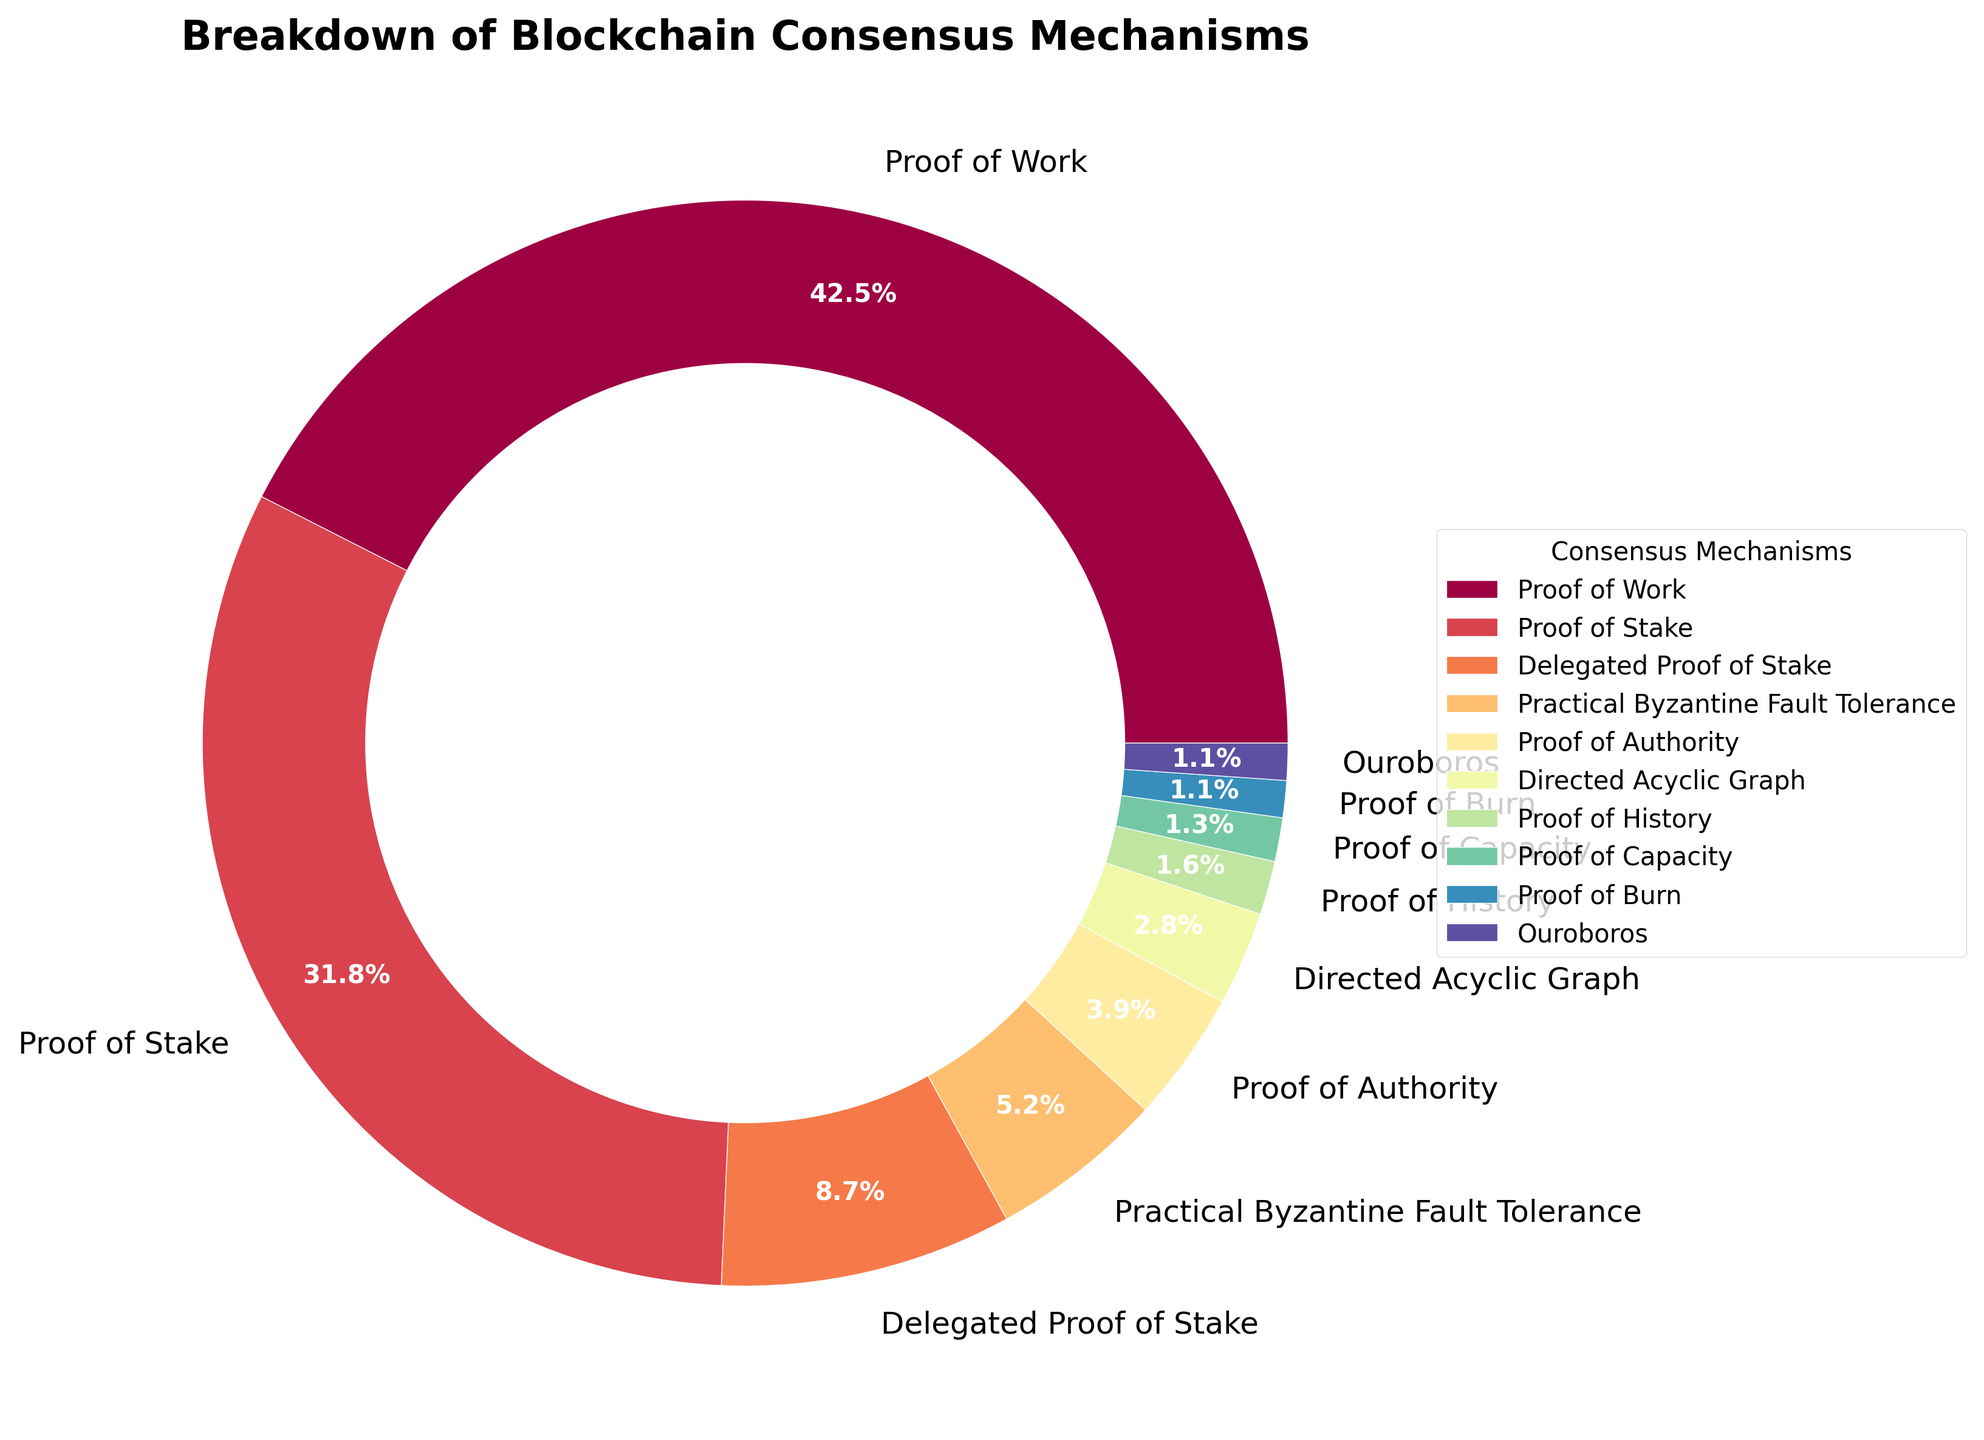What is the most commonly used blockchain consensus mechanism according to the chart? The slice representing Proof of Work is the largest part of the pie chart. Therefore, Proof of Work is the most commonly used consensus mechanism.
Answer: Proof of Work What percentage of top cryptocurrencies use Proof of Stake? The chart shows a label for Proof of Stake indicating its percentage.
Answer: 31.8% How much higher is the percentage of Proof of Work compared to Proof of Stake? Proof of Work has a percentage of 42.5%, and Proof of Stake has a percentage of 31.8%. Subtracting these two values gives the difference: 42.5% - 31.8% = 10.7%.
Answer: 10.7% Which consensus mechanisms combined make up more than 50% of the chart? Adding the percentages of each consensus mechanism, starting with the largest values: Proof of Work (42.5%) and Proof of Stake (31.8%). Their combined percentage is 42.5% + 31.8% = 74.3%, which is more than 50%.
Answer: Proof of Work and Proof of Stake List all the consensus mechanisms that have a percentage lower than 3%. Identify the slices of the pie chart that have percentages below 3%. These mechanisms are Directed Acyclic Graph (2.8%), Proof of History (1.6%), Proof of Capacity (1.3%), Proof of Burn (1.1%), and Ouroboros (1.1%).
Answer: Directed Acyclic Graph, Proof of History, Proof of Capacity, Proof of Burn, Ouroboros Which consensus mechanism occupies the smallest segment in the chart? The segment labeled with the smallest percentage represents Proof of Burn and Ouroboros, both showing 1.1%. Since they have the same percentage, either could be considered the smallest.
Answer: Proof of Burn/Ouroboros How do the percentages of Delegated Proof of Stake and Practical Byzantine Fault Tolerance compare? The percentage for Delegated Proof of Stake is 8.7%, while Practical Byzantine Fault Tolerance has 5.2%. Comparing the two, 8.7% is greater than 5.2%.
Answer: Delegated Proof of Stake is greater than Practical Byzantine Fault Tolerance If you were to combine the percentages of Proof of Authority and Directed Acyclic Graph, what would be their total percentage? The chart shows that Proof of Authority has 3.9%, and Directed Acyclic Graph has 2.8%. Adding these together gives 3.9% + 2.8% = 6.7%.
Answer: 6.7% Out of Proof of Capacity, Proof of Burn, and Ouroboros, which of these mechanisms has the same percentage? The chart shows Proof of Burn and Ouroboros each have a percentage of 1.1%.
Answer: Proof of Burn and Ouroboros On average, what percentage does each consensus mechanism take if we consider only those with less than 3% individually? Adding the percentages of Directed Acyclic Graph (2.8%), Proof of History (1.6%), Proof of Capacity (1.3%), Proof of Burn (1.1%), and Ouroboros (1.1%): 2.8% + 1.6% + 1.3% + 1.1% + 1.1% = 7.9%. Dividing by the number of mechanisms (5) gives 7.9% / 5 = 1.58%.
Answer: 1.58% 